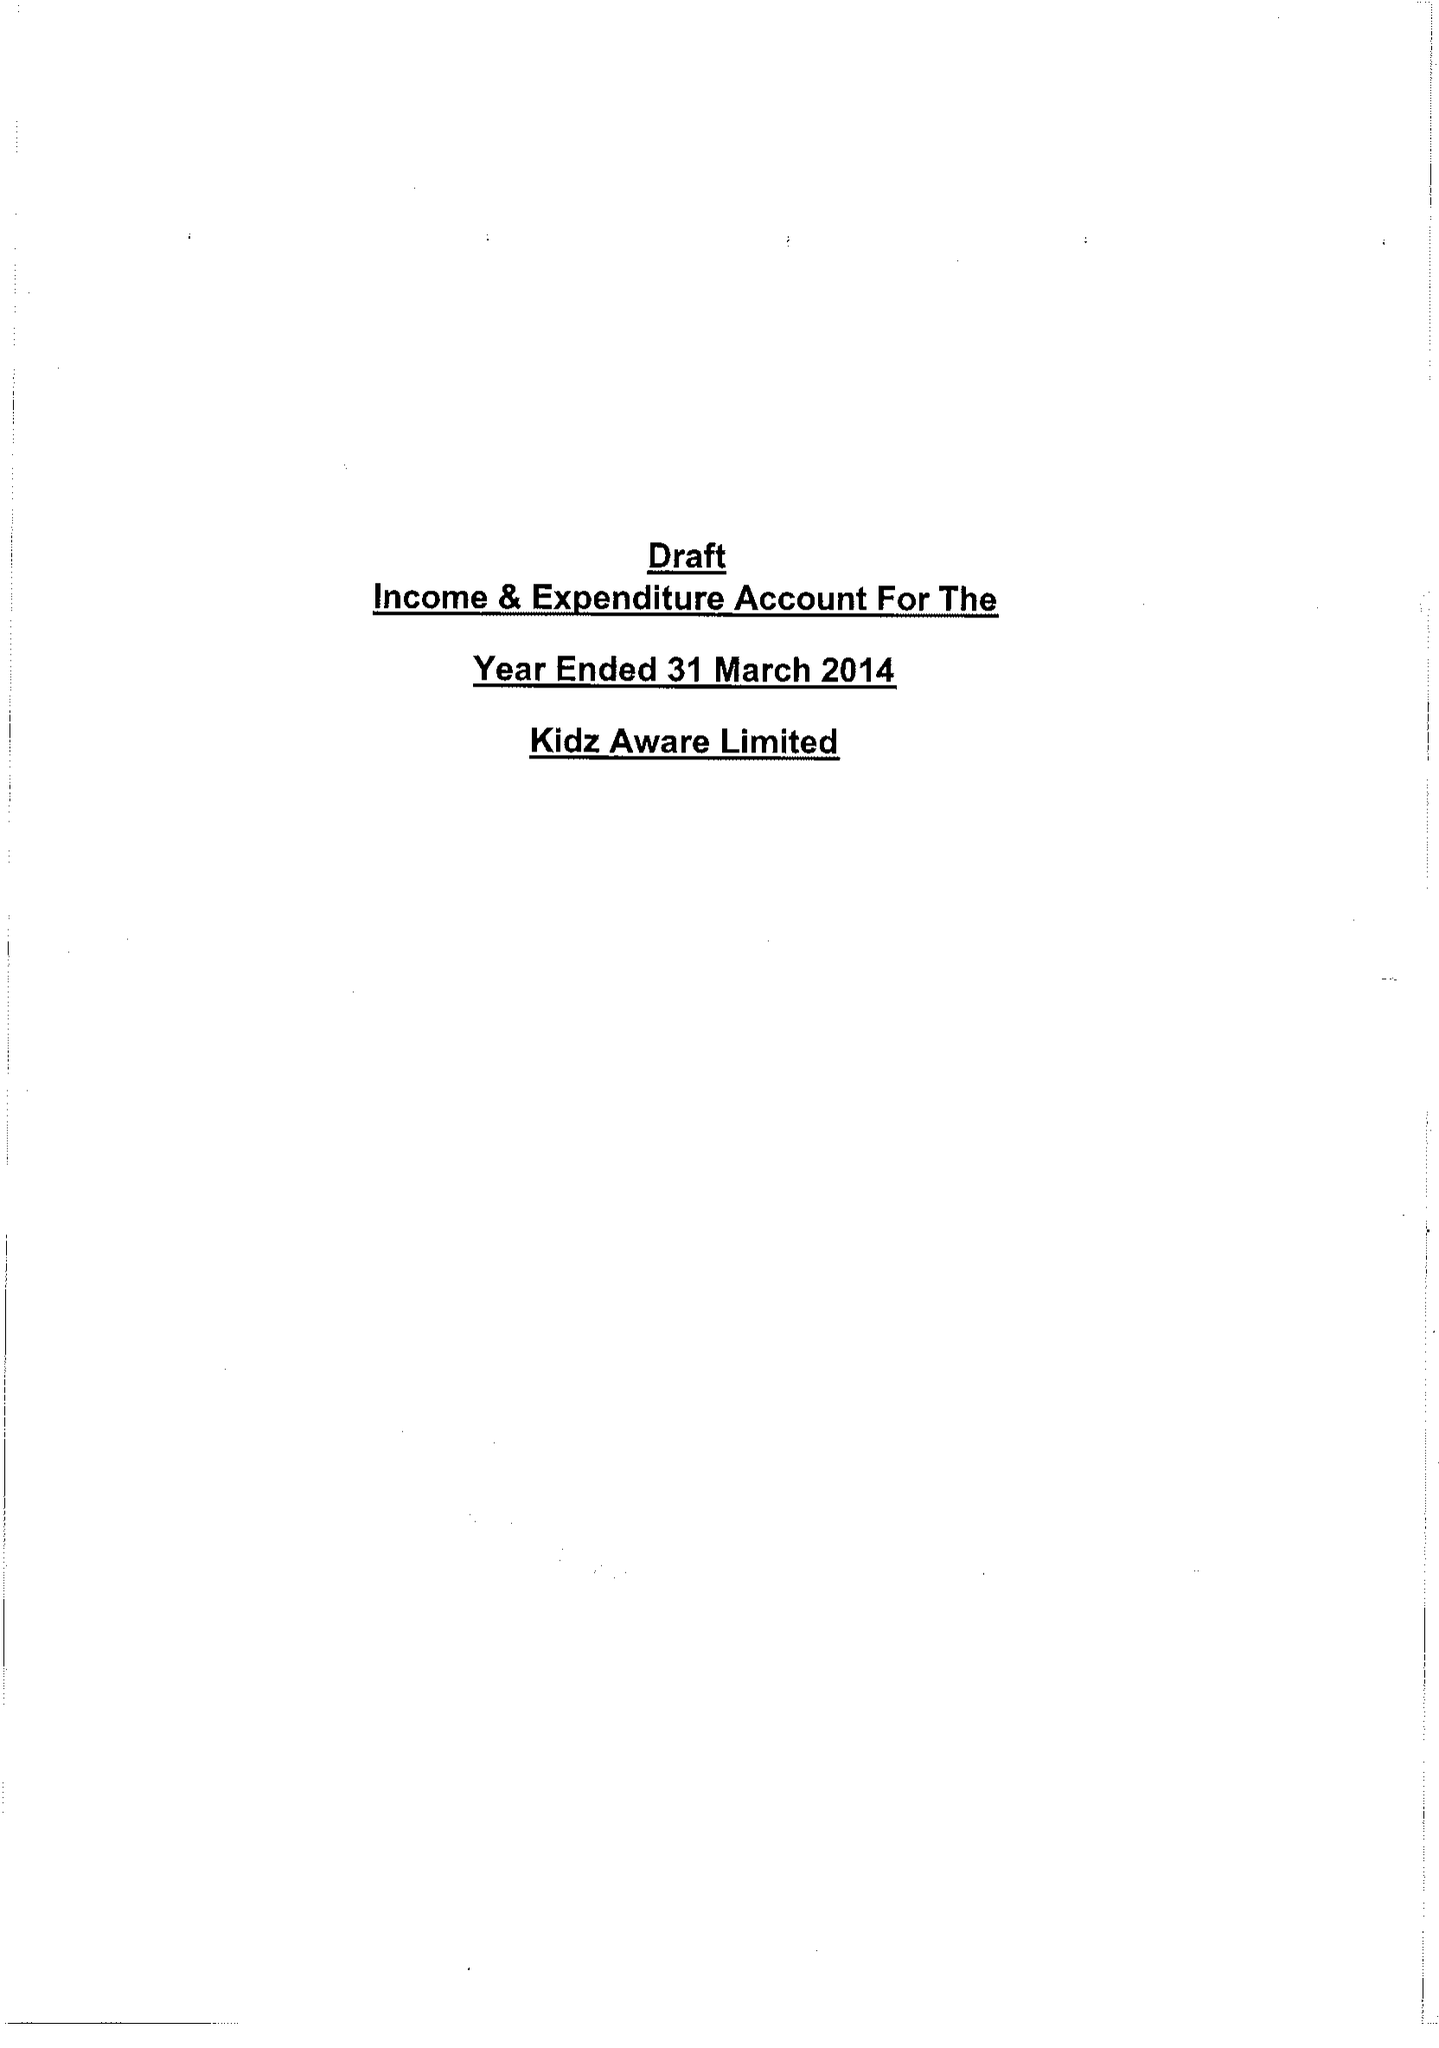What is the value for the charity_number?
Answer the question using a single word or phrase. 1118859 